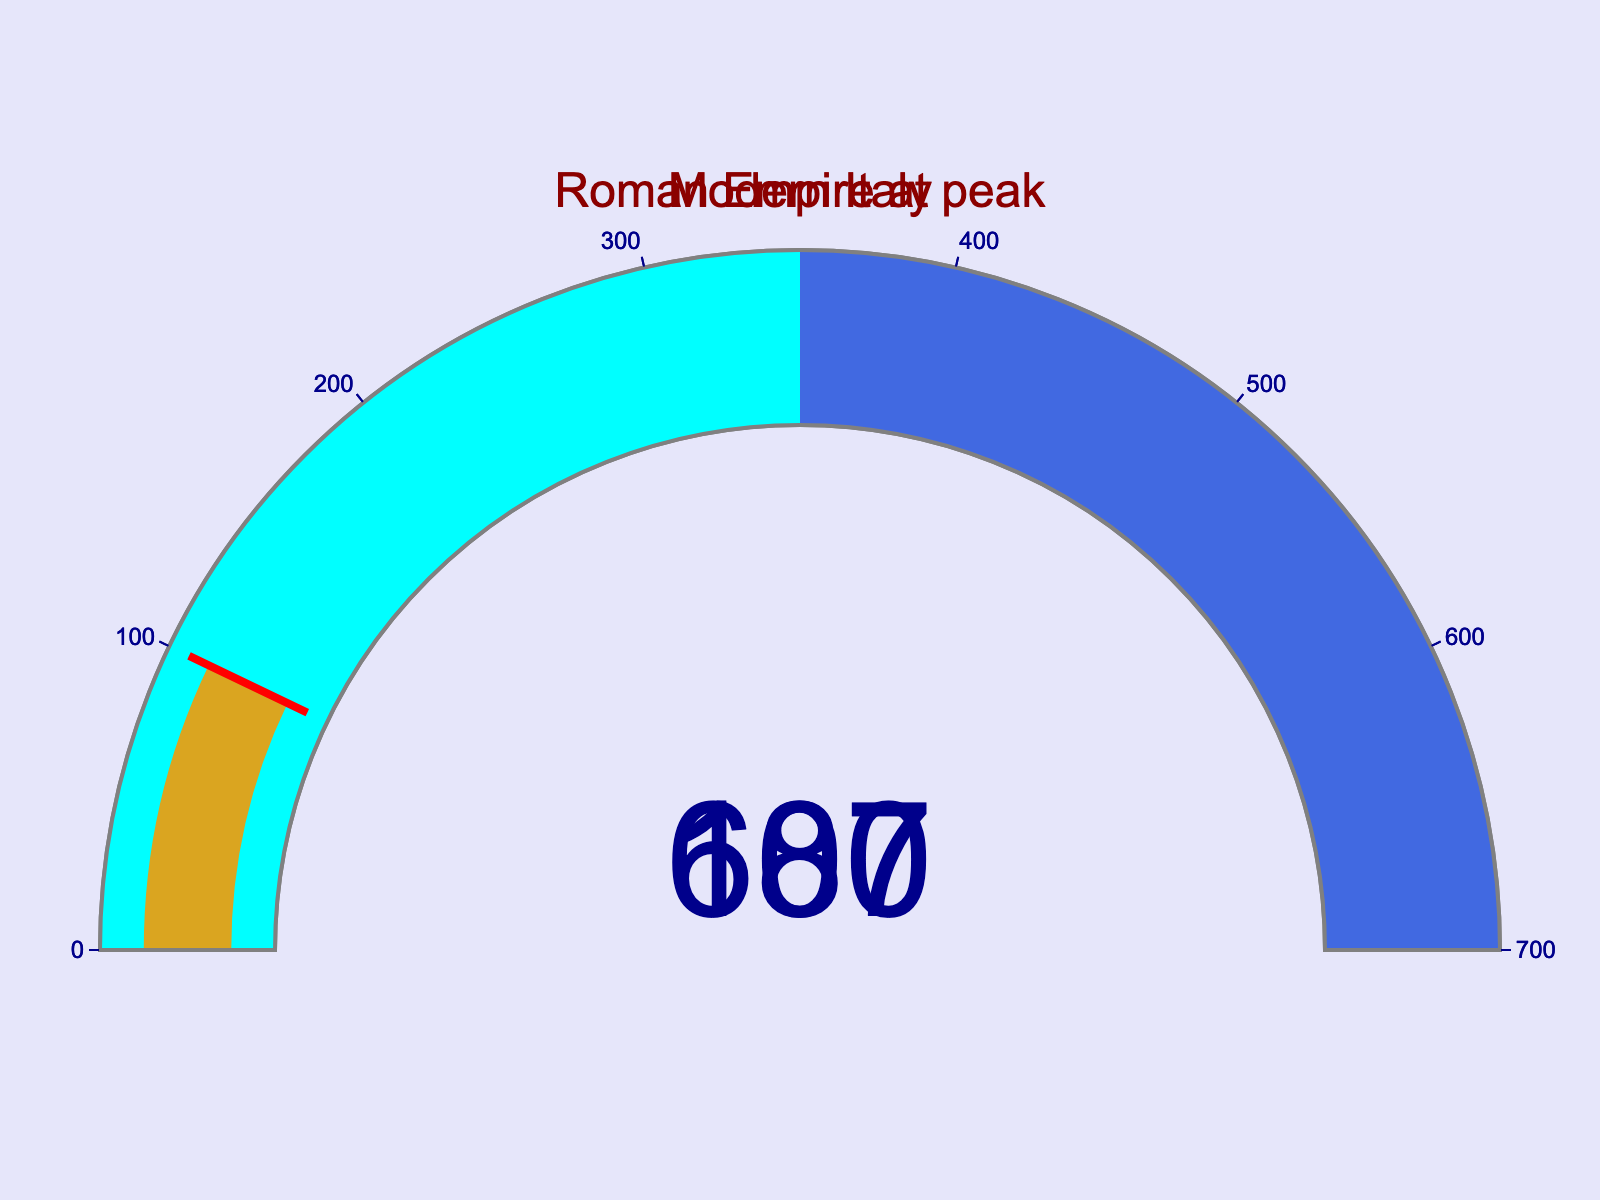What are the two territories displayed on the gauge charts? The gauge charts show the territories of the Roman Empire at its peak and modern-day Italy.
Answer: Roman Empire at peak, Modern Italy What is the value displayed for the Roman Empire at its peak on the gauge chart? The value displayed on the gauge chart for the Roman Empire at its peak is 687, which represents the proportion of the Roman Empire's territory compared to modern-day Italy.
Answer: 687 What color represents the gauge bar for both territories? The gauge bars for both territories are represented in goldenrod color.
Answer: goldenrod What is the range used for the gauge axis? The range for the gauge axis in both charts is from 0 to 700.
Answer: 0-700 How much larger in percentage terms was the Roman Empire at its peak compared to modern-day Italy? The Roman Empire at its peak is shown to have a percentage value of 687 compared to modern Italy's 100. The difference is 687 - 100 = 587 percentage points.
Answer: 587 What are the two colors used for the gauge steps aside from the main bar color? The two colors used for the gauge steps are cyan and royal blue.
Answer: cyan, royal blue What is the difference between the highest value in the gauge chart and the modern-day Italy value? The highest value in the gauge chart is 687 (for the Roman Empire at its peak) and the value for modern-day Italy is 100. The difference is 687 - 100 = 587.
Answer: 587 Which gauge has a threshold line, and what color is it? Both gauges have a threshold line, and the color of the threshold line is red.
Answer: both, red What can you infer about the size of the Roman Empire at its peak compared to modern-day Italy based on the gauge chart? The gauge chart shows that the Roman Empire at its peak was significantly larger than modern-day Italy, with the Roman Empire's value being 687% of modern-day Italy's size.
Answer: significantly larger How are the gauge charts visually distinguished from each other in terms of layout? Both gauge charts are displayed next to each other in a single row on the figure to visually distinguish them.
Answer: single row 